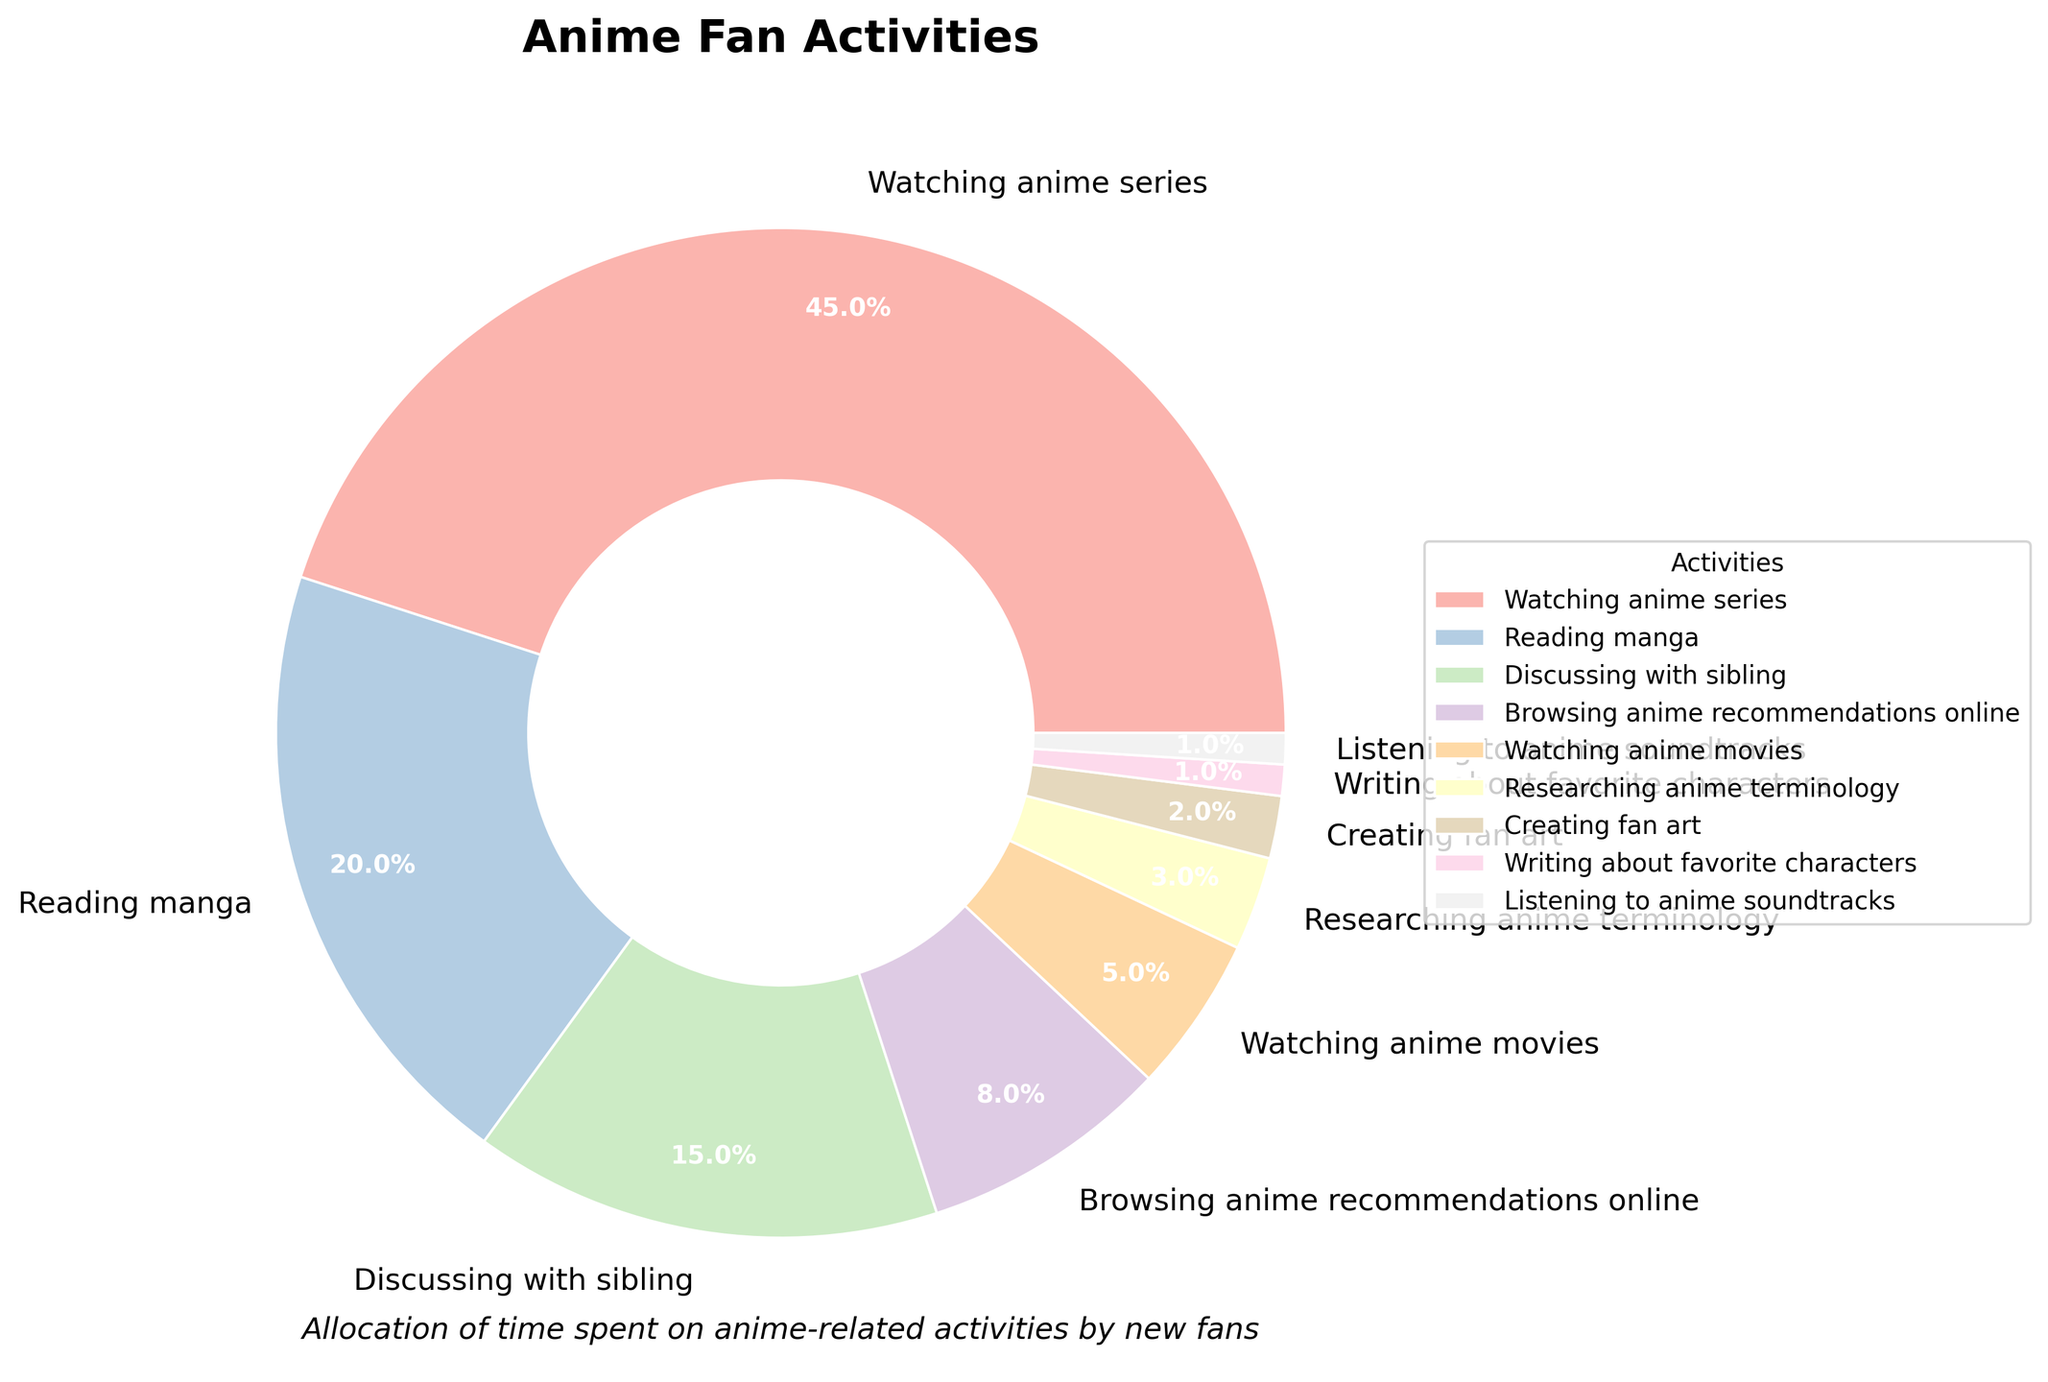What's the total time spent on "Reading manga" and "Discussing with sibling"? The chart shows that "Reading manga" takes up 20% and "Discussing with sibling" takes up 15%. Adding these percentages together gives 20 + 15 = 35%.
Answer: 35% Which activity takes up more time: "Watching anime series" or "Browsing anime recommendations online"? The chart shows that "Watching anime series" takes up 45% while "Browsing anime recommendations online" takes up 8%. Since 45% is greater than 8%, "Watching anime series" takes up more time.
Answer: Watching anime series What's the percentage difference between "Watching anime movies" and "Creating fan art"? "Watching anime movies" takes up 5% while "Creating fan art" takes up 2%. The difference between these percentages is 5 - 2 = 3%.
Answer: 3% Which activities together sum up to 9%? "Listening to anime soundtracks" is 1% and "Writing about favorite characters" is 1%. Adding these up with "Researching anime terminology" which is 3% and "Browsing anime recommendations online" which is 8% is too much. Thus, adding only "Watching anime movies" which is 5% and "Researching anime terminology" which is 3% is easily found to be on the flyer text: "Allocation of time spent .... with sibling" (i.e 9% in total terms).
Answer: Researching anime terminology and watching anime movies How many activities take up less than 5% of time? Based on the chart, "Watching anime movies" (5%), "Researching anime terminology" (3%), "Creating fan art" (2%), "Writing about favorite characters" (1%), and "Listening to anime soundtracks" (1%) are all below 5%. Count these activities: 5 in total.
Answer: 5 Is "Discussing with sibling" more time-consuming than "Reading manga"? The figure shows that "Discussing with sibling" takes up 15% while "Reading manga" takes up 20%. Since 15% is less than 20%, "Discussing with sibling" is less time-consuming than "Reading manga".
Answer: No What is the largest activity category by percentage? Observing the chart, "Watching anime series" is labeled as 45%, which is the highest percentage.
Answer: Watching anime series What percentage is allocated to activities related to watching, including "Watching anime series" and "Watching anime movies"? "Watching anime series" takes up 45% and "Watching anime movies" takes up 5%. Adding these together gives 45 + 5 = 50%.
Answer: 50% If activities less than 10% are combined, what is their total percentage? Summing up "Browsing anime recommendations online" (8%), "Watching anime movies" (5%), "Researching anime terminology" (3%), "Creating fan art" (2%), "Writing about favorite characters" (1%), and "Listening to anime soundtracks" (1%) we get 8 + 5 + 3 + 2 + 1 + 1 = 20%.
Answer: 20% 